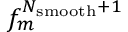<formula> <loc_0><loc_0><loc_500><loc_500>f _ { m } ^ { N _ { s m o o t h } + 1 }</formula> 